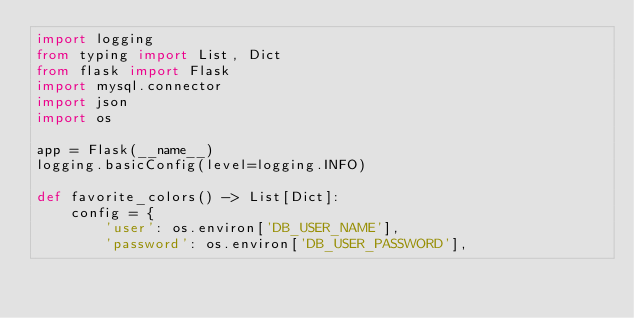Convert code to text. <code><loc_0><loc_0><loc_500><loc_500><_Python_>import logging
from typing import List, Dict
from flask import Flask
import mysql.connector
import json
import os

app = Flask(__name__)
logging.basicConfig(level=logging.INFO)

def favorite_colors() -> List[Dict]:
    config = {
        'user': os.environ['DB_USER_NAME'],
        'password': os.environ['DB_USER_PASSWORD'],</code> 